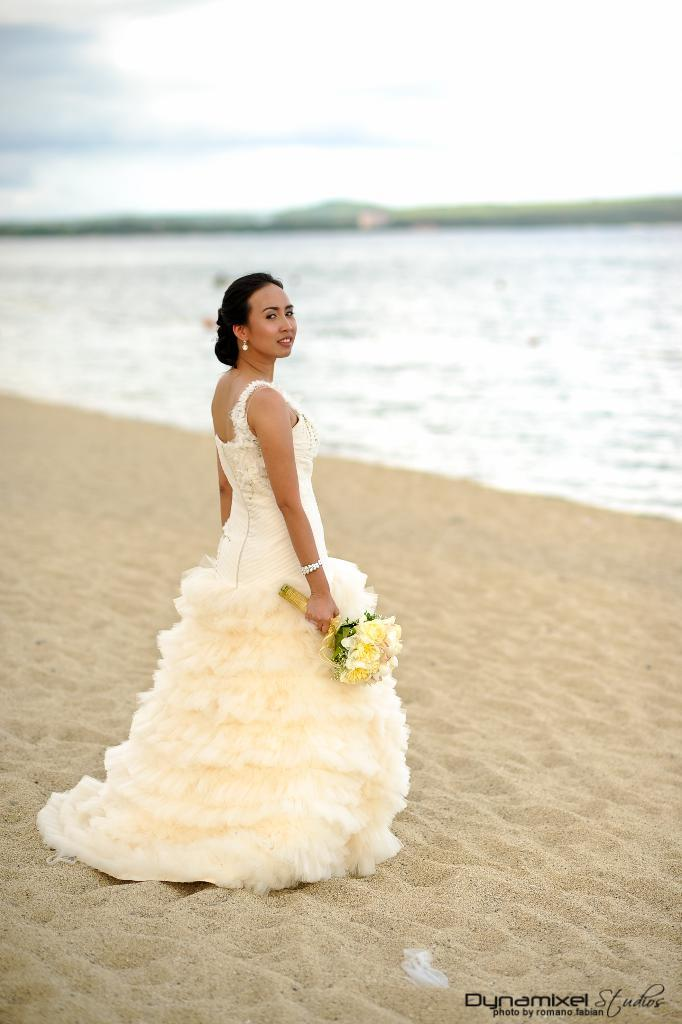Who is present in the image? There is a woman in the image. What is the woman doing in the image? The woman is standing in the image. What is the woman wearing? The woman is wearing a white dress. What is the woman holding in her hands? The woman is holding a bokeh in her hands. What is in front of the woman? There is water in front of the woman. What can be seen above the water? The sky is visible above the water. How many bikes are parked near the woman in the image? There are no bikes present in the image. Are there any dogs visible in the image? There are no dogs present in the image. 